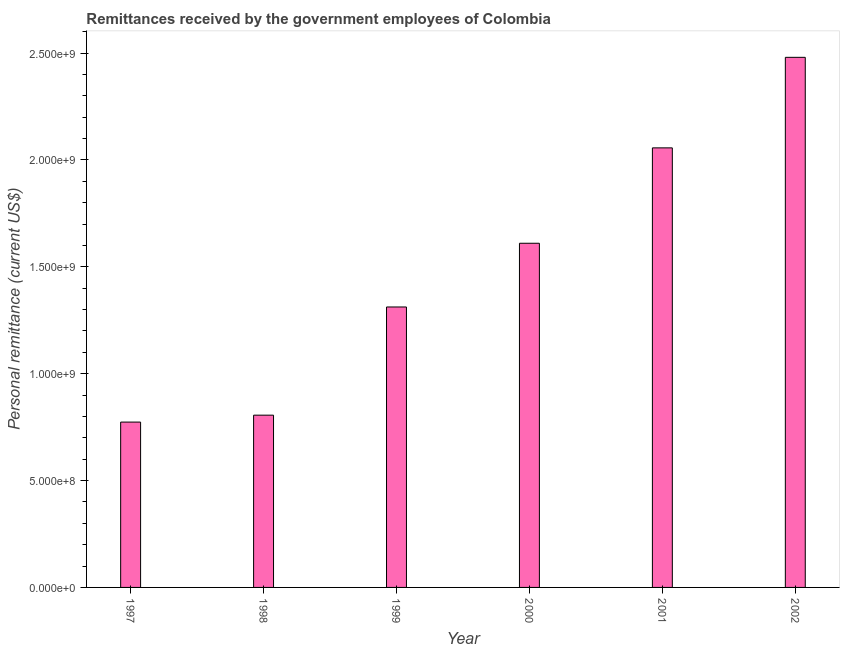What is the title of the graph?
Give a very brief answer. Remittances received by the government employees of Colombia. What is the label or title of the Y-axis?
Give a very brief answer. Personal remittance (current US$). What is the personal remittances in 2002?
Keep it short and to the point. 2.48e+09. Across all years, what is the maximum personal remittances?
Your answer should be compact. 2.48e+09. Across all years, what is the minimum personal remittances?
Your response must be concise. 7.74e+08. In which year was the personal remittances minimum?
Provide a succinct answer. 1997. What is the sum of the personal remittances?
Offer a terse response. 9.04e+09. What is the difference between the personal remittances in 2000 and 2002?
Your response must be concise. -8.70e+08. What is the average personal remittances per year?
Your answer should be compact. 1.51e+09. What is the median personal remittances?
Ensure brevity in your answer.  1.46e+09. Do a majority of the years between 2002 and 1997 (inclusive) have personal remittances greater than 1100000000 US$?
Keep it short and to the point. Yes. What is the ratio of the personal remittances in 1997 to that in 2000?
Offer a terse response. 0.48. Is the difference between the personal remittances in 1997 and 1999 greater than the difference between any two years?
Offer a terse response. No. What is the difference between the highest and the second highest personal remittances?
Keep it short and to the point. 4.24e+08. What is the difference between the highest and the lowest personal remittances?
Ensure brevity in your answer.  1.71e+09. How many bars are there?
Provide a short and direct response. 6. How many years are there in the graph?
Provide a succinct answer. 6. What is the difference between two consecutive major ticks on the Y-axis?
Provide a short and direct response. 5.00e+08. What is the Personal remittance (current US$) of 1997?
Provide a short and direct response. 7.74e+08. What is the Personal remittance (current US$) of 1998?
Give a very brief answer. 8.06e+08. What is the Personal remittance (current US$) in 1999?
Provide a succinct answer. 1.31e+09. What is the Personal remittance (current US$) of 2000?
Offer a terse response. 1.61e+09. What is the Personal remittance (current US$) of 2001?
Provide a succinct answer. 2.06e+09. What is the Personal remittance (current US$) of 2002?
Make the answer very short. 2.48e+09. What is the difference between the Personal remittance (current US$) in 1997 and 1998?
Provide a short and direct response. -3.24e+07. What is the difference between the Personal remittance (current US$) in 1997 and 1999?
Your response must be concise. -5.39e+08. What is the difference between the Personal remittance (current US$) in 1997 and 2000?
Offer a terse response. -8.37e+08. What is the difference between the Personal remittance (current US$) in 1997 and 2001?
Your answer should be compact. -1.28e+09. What is the difference between the Personal remittance (current US$) in 1997 and 2002?
Offer a very short reply. -1.71e+09. What is the difference between the Personal remittance (current US$) in 1998 and 1999?
Provide a short and direct response. -5.06e+08. What is the difference between the Personal remittance (current US$) in 1998 and 2000?
Provide a short and direct response. -8.04e+08. What is the difference between the Personal remittance (current US$) in 1998 and 2001?
Provide a succinct answer. -1.25e+09. What is the difference between the Personal remittance (current US$) in 1998 and 2002?
Your response must be concise. -1.67e+09. What is the difference between the Personal remittance (current US$) in 1999 and 2000?
Provide a succinct answer. -2.98e+08. What is the difference between the Personal remittance (current US$) in 1999 and 2001?
Provide a succinct answer. -7.44e+08. What is the difference between the Personal remittance (current US$) in 1999 and 2002?
Provide a short and direct response. -1.17e+09. What is the difference between the Personal remittance (current US$) in 2000 and 2001?
Offer a very short reply. -4.46e+08. What is the difference between the Personal remittance (current US$) in 2000 and 2002?
Give a very brief answer. -8.70e+08. What is the difference between the Personal remittance (current US$) in 2001 and 2002?
Give a very brief answer. -4.24e+08. What is the ratio of the Personal remittance (current US$) in 1997 to that in 1999?
Your answer should be compact. 0.59. What is the ratio of the Personal remittance (current US$) in 1997 to that in 2000?
Your answer should be very brief. 0.48. What is the ratio of the Personal remittance (current US$) in 1997 to that in 2001?
Provide a succinct answer. 0.38. What is the ratio of the Personal remittance (current US$) in 1997 to that in 2002?
Keep it short and to the point. 0.31. What is the ratio of the Personal remittance (current US$) in 1998 to that in 1999?
Your response must be concise. 0.61. What is the ratio of the Personal remittance (current US$) in 1998 to that in 2000?
Offer a terse response. 0.5. What is the ratio of the Personal remittance (current US$) in 1998 to that in 2001?
Make the answer very short. 0.39. What is the ratio of the Personal remittance (current US$) in 1998 to that in 2002?
Your response must be concise. 0.33. What is the ratio of the Personal remittance (current US$) in 1999 to that in 2000?
Your answer should be compact. 0.81. What is the ratio of the Personal remittance (current US$) in 1999 to that in 2001?
Give a very brief answer. 0.64. What is the ratio of the Personal remittance (current US$) in 1999 to that in 2002?
Make the answer very short. 0.53. What is the ratio of the Personal remittance (current US$) in 2000 to that in 2001?
Offer a terse response. 0.78. What is the ratio of the Personal remittance (current US$) in 2000 to that in 2002?
Your answer should be very brief. 0.65. What is the ratio of the Personal remittance (current US$) in 2001 to that in 2002?
Your answer should be very brief. 0.83. 